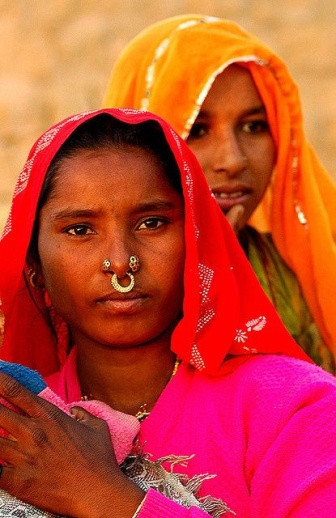What emotions does the image evoke? The image evokes a blend of admiration and curiosity. The traditional attire and confident expressions of the women inspire respect for their cultural heritage. There is a profound sense of pride, resilience, and unity, but also a curiosity about their lives, stories, and the customs they honor. 